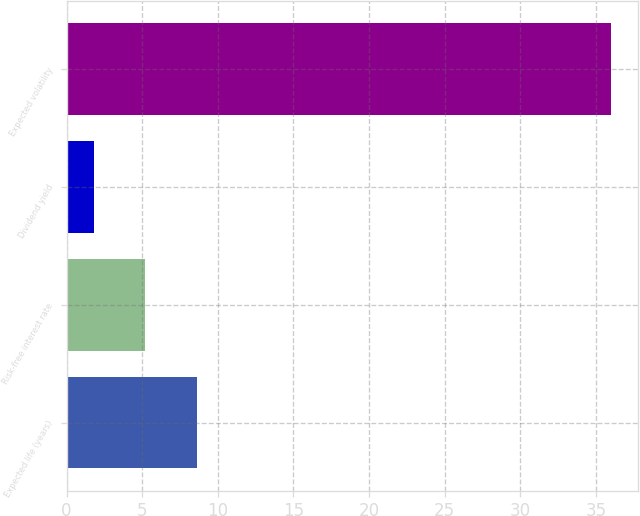Convert chart. <chart><loc_0><loc_0><loc_500><loc_500><bar_chart><fcel>Expected life (years)<fcel>Risk-free interest rate<fcel>Dividend yield<fcel>Expected volatility<nl><fcel>8.64<fcel>5.22<fcel>1.8<fcel>36<nl></chart> 